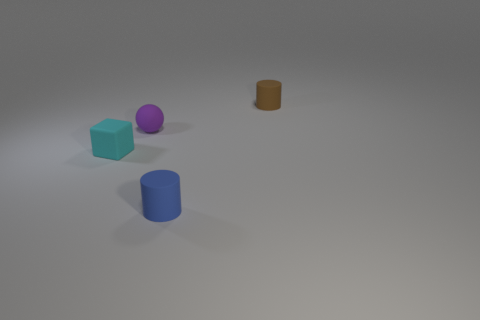Which objects in the image seem to be light sources based on the shadows you can see? Considering the shadows, there don't appear to be any objects in the image that are light sources themselves. However, shadows and lighting suggest an external light source not visible in the frame. 